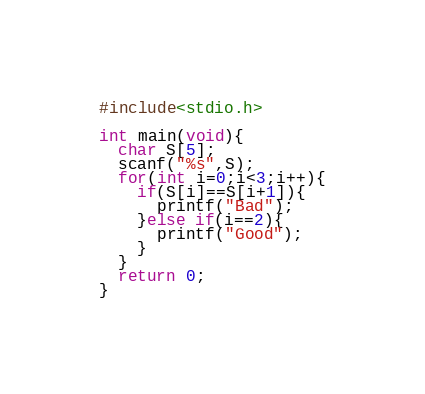Convert code to text. <code><loc_0><loc_0><loc_500><loc_500><_C_>#include<stdio.h>
 
int main(void){
  char S[5];
  scanf("%s",S);
  for(int i=0;i<3;i++){
    if(S[i]==S[i+1]){
      printf("Bad");
    }else if(i==2){
      printf("Good");
    }
  }
  return 0;
}</code> 